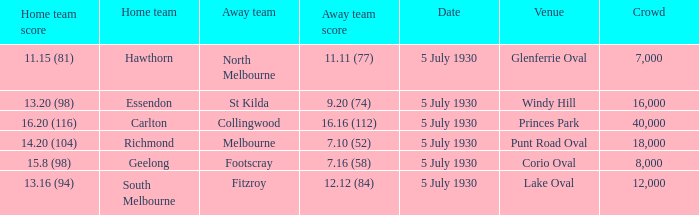What is the venue when fitzroy was the away team? Lake Oval. 